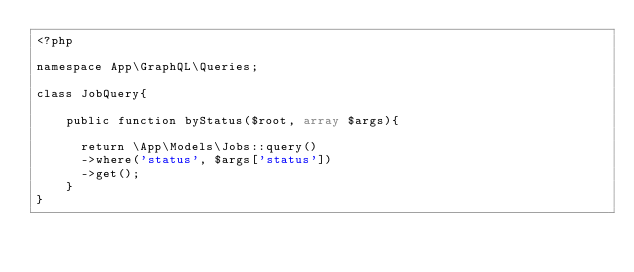Convert code to text. <code><loc_0><loc_0><loc_500><loc_500><_PHP_><?php 

namespace App\GraphQL\Queries;

class JobQuery{

    public function byStatus($root, array $args){

      return \App\Models\Jobs::query()
      ->where('status', $args['status'])
      ->get();
    }
}</code> 